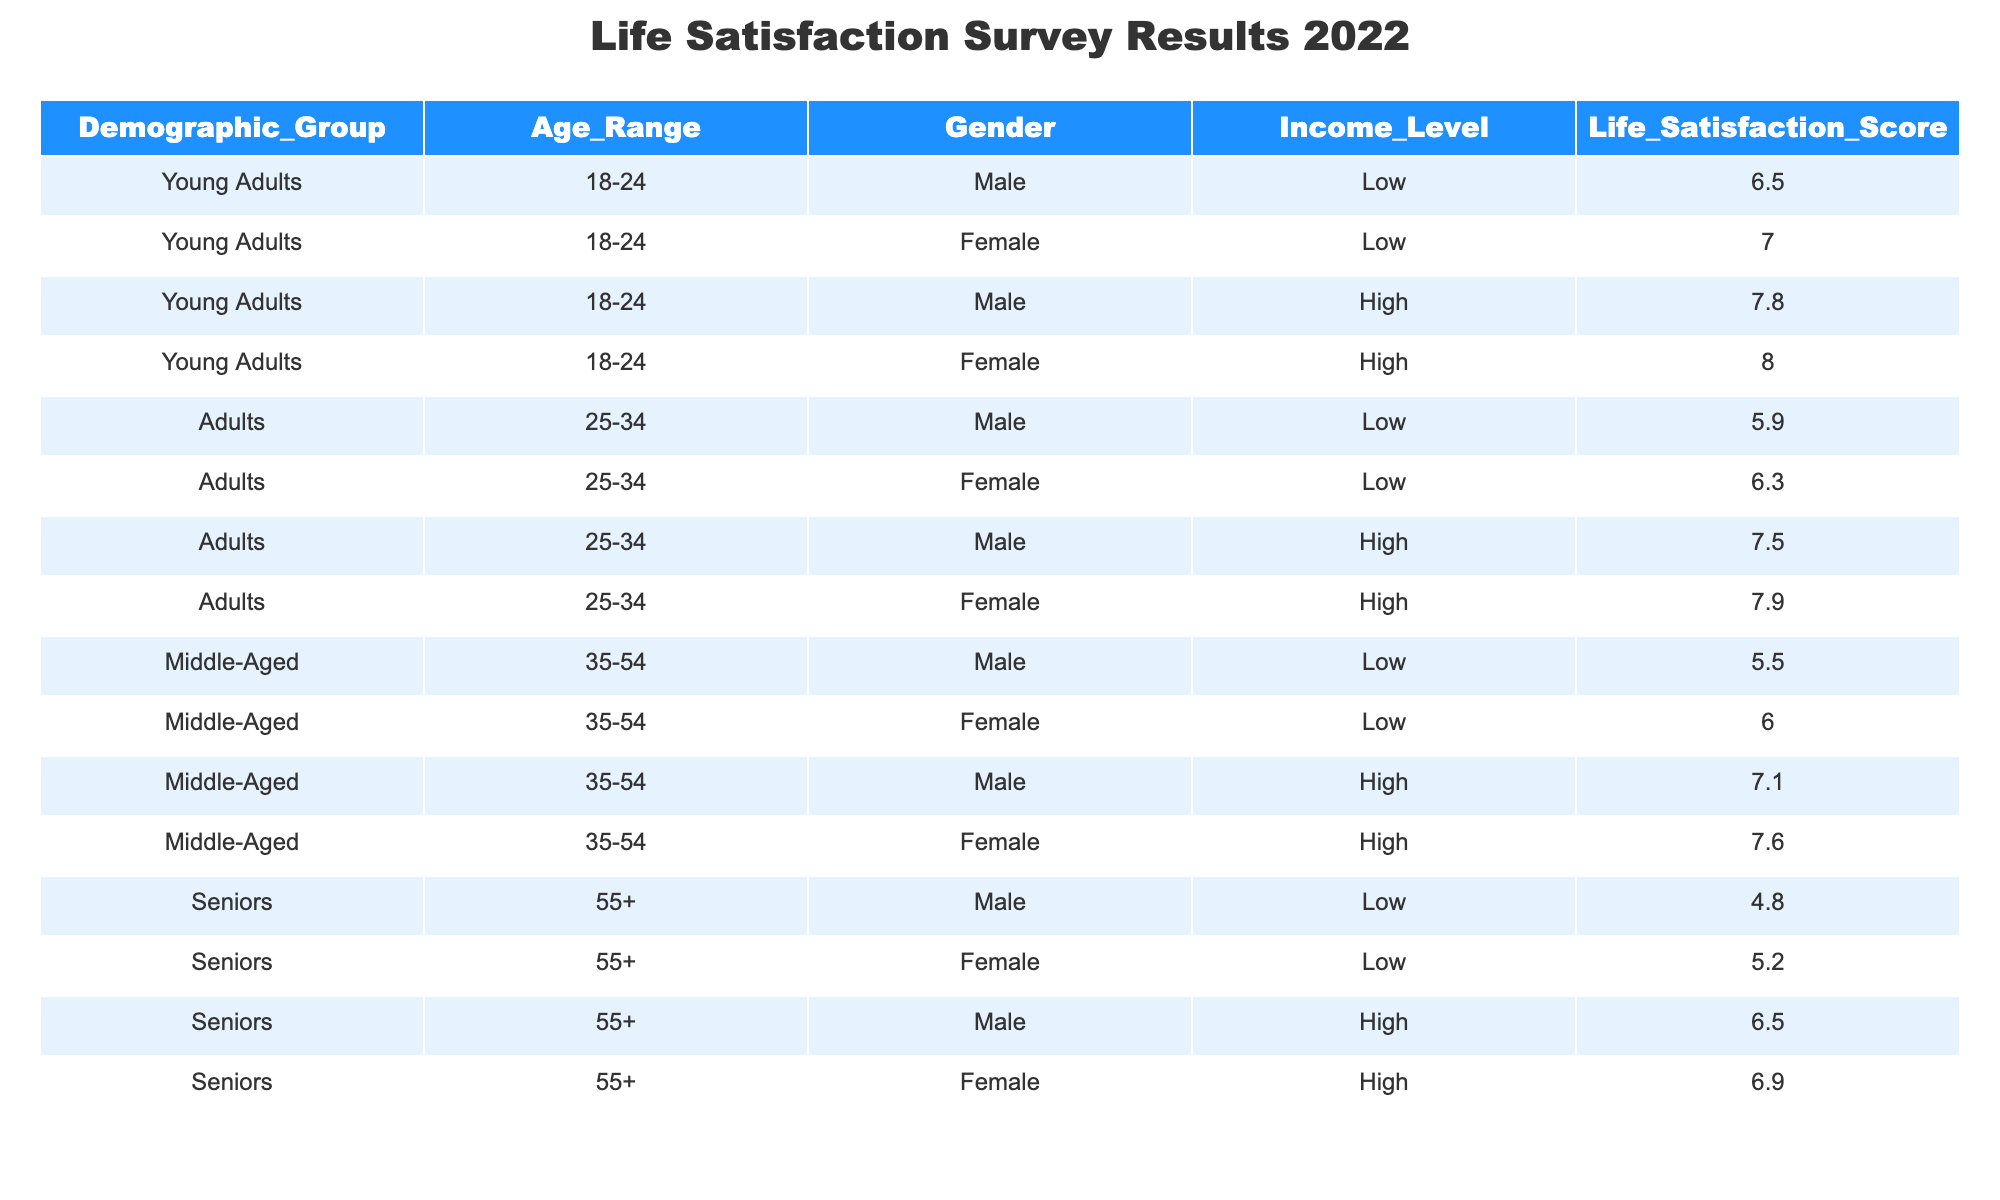What is the life satisfaction score for young adult females with a low income? The table shows that for young adult females in the low-income category, the life satisfaction score is 7.0.
Answer: 7.0 What is the highest life satisfaction score among middle-aged males? The table indicates that the highest life satisfaction score for middle-aged males is 7.1, which is for the high-income category.
Answer: 7.1 Is the life satisfaction score for senior females higher than that for senior males in the low-income category? For senior females in the low-income category, the score is 5.2, while for senior males, it is 4.8. Since 5.2 is greater than 4.8, the answer is yes.
Answer: Yes What is the average life satisfaction score for adults aged 25-34? The life satisfaction scores for adults aged 25-34 are 5.9, 6.3, 7.5, and 7.9. To find the average, we sum these scores (5.9 + 6.3 + 7.5 + 7.9 = 27.6) and divide by the number of data points (4). Hence, the average is 27.6 / 4 = 6.9.
Answer: 6.9 Do senior males generally report higher life satisfaction than middle-aged males? Senior males have life satisfaction scores of 4.8 (low income) and 6.5 (high income), averaging to 5.65. Middle-aged males report scores of 5.5 (low income) and 7.1 (high income), averaging to 6.3. Since 5.65 is less than 6.3, the answer is no.
Answer: No What is the difference in life satisfaction scores between young adults with high income and those with low income, specifically males? The life satisfaction score for young adult males with high income is 7.8, and for those with low income, it is 6.5. The difference is 7.8 - 6.5 = 1.3.
Answer: 1.3 What is the life satisfaction score for middle-aged females in the low-income category? The table specifically states that the life satisfaction score for middle-aged females with a low income is 6.0.
Answer: 6.0 Which demographic group has the lowest life satisfaction score overall? By reviewing all the scores in the table, seniors in the low-income category (4.8 for males) have the lowest score among all groups and genders.
Answer: Seniors in low income (4.8) What percentage of young adults report a life satisfaction score above 7.5? Young adults with scores above 7.5 are those with high income: male (7.8) and female (8.0), totaling 2 out of 4 young adults. This gives us (2/4) * 100% = 50%.
Answer: 50% 